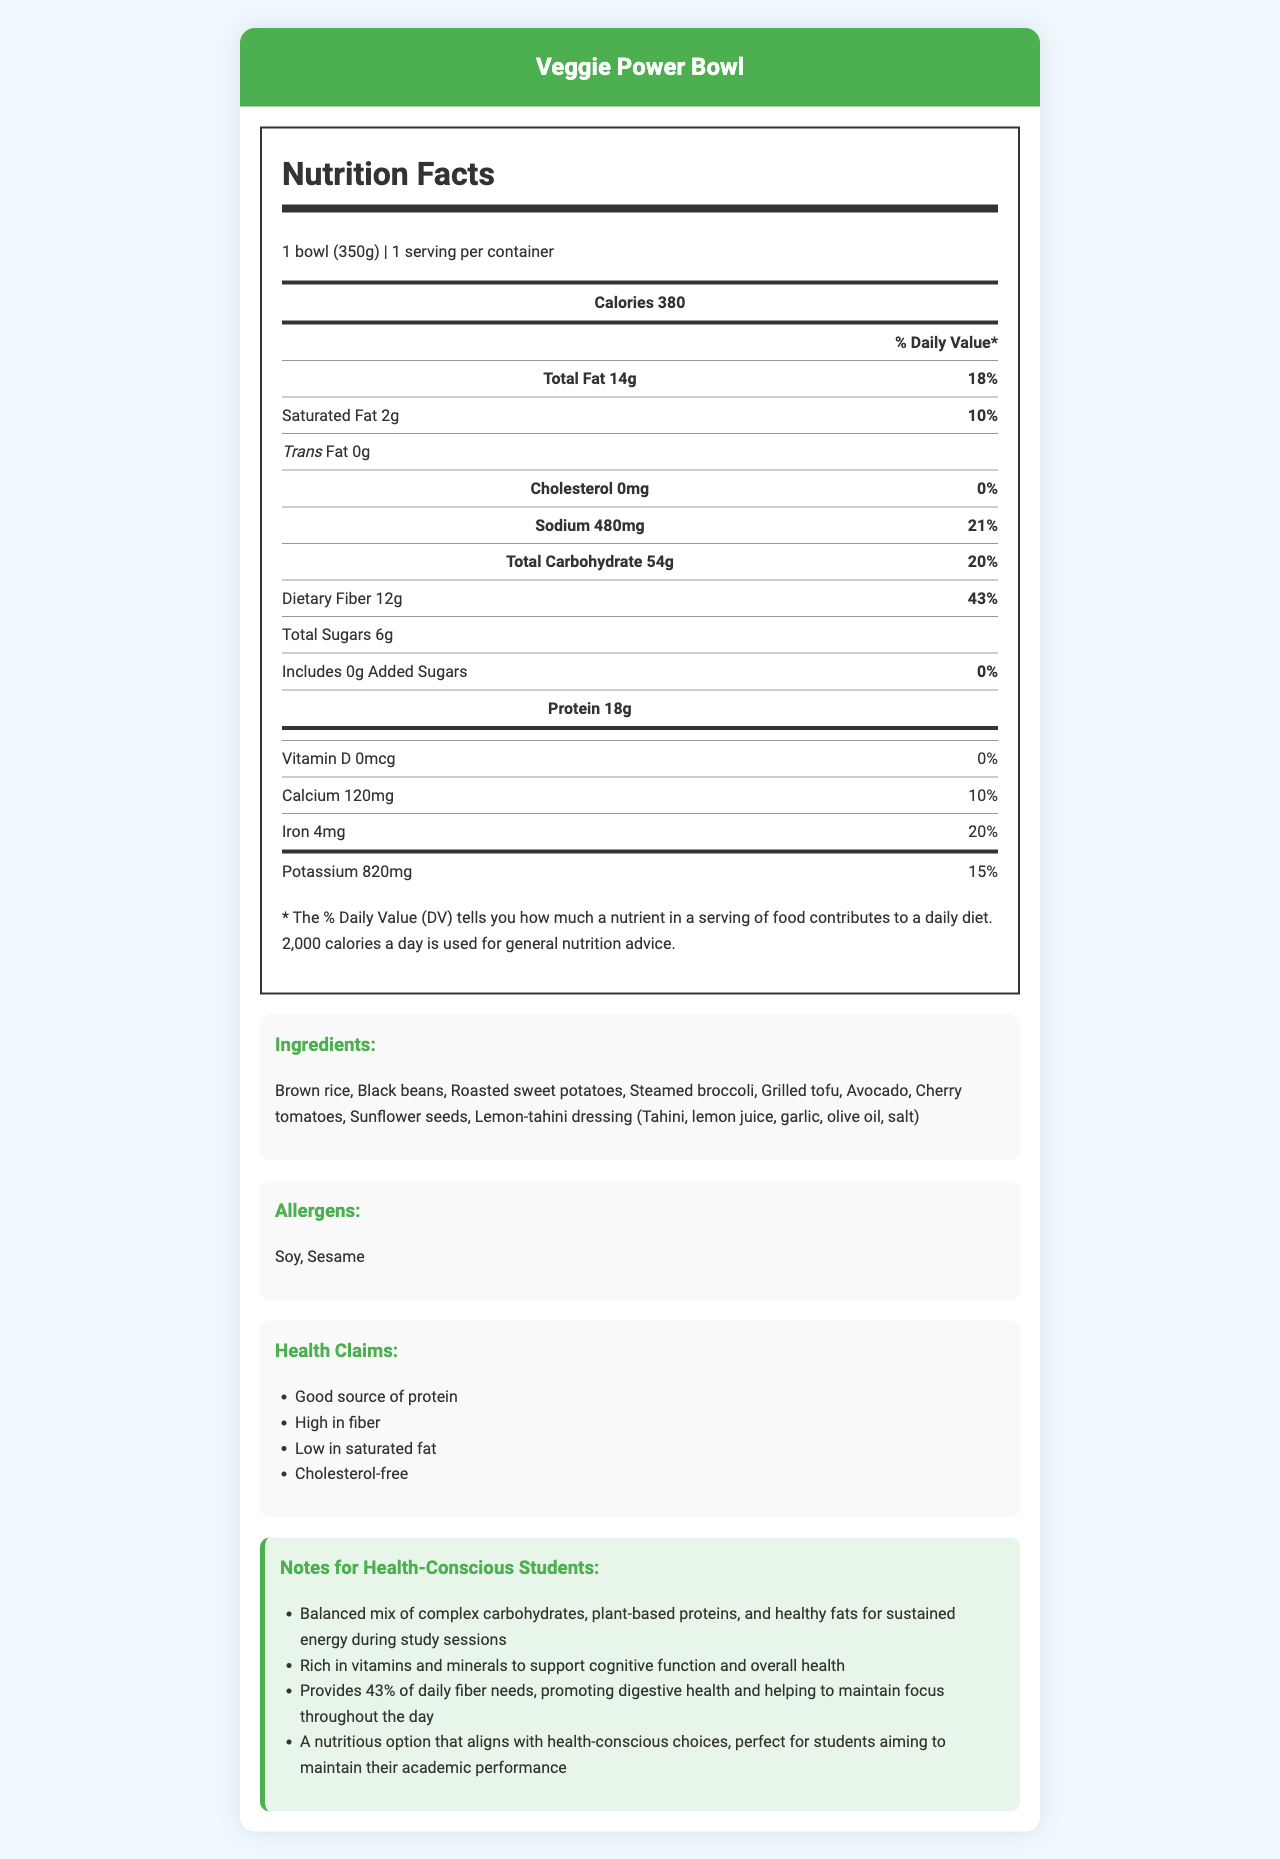what is the calorie count for one serving of the Veggie Power Bowl? The nutrition label states that one serving of the Veggie Power Bowl contains 380 calories.
Answer: 380 How much dietary fiber is in one Veggie Power Bowl? The nutrition label indicates that the Veggie Power Bowl contains 12g of dietary fiber per serving.
Answer: 12g What is the daily value percentage for sodium in the Veggie Power Bowl? The nutrition label shows that the Veggie Power Bowl provides 21% of the daily value for sodium.
Answer: 21% Which ingredient(s) in the Veggie Power Bowl might cause allergies? The allergens section lists soy and sesame as potential allergens.
Answer: Soy and Sesame How much protein is in the Veggie Power Bowl? The nutrition label specifies that the Veggie Power Bowl contains 18g of protein per serving.
Answer: 18g What percentage of the daily value of calcium does one serving provide? The nutrition label shows that one serving provides 10% of the daily value for calcium.
Answer: 10% Is the Veggie Power Bowl cholesterol-free? The nutrition label states that the Veggie Power Bowl contains 0mg of cholesterol, meaning it is cholesterol-free.
Answer: Yes How many grams of total fat are in one Veggie Power Bowl? According to the nutrition label, one serving of the Veggie Power Bowl contains 14g of total fat.
Answer: 14g Which of the following is a health claim made about the Veggie Power Bowl? (A) Low in sodium (B) Good source of protein (C) Contains added sugars The health claims section lists "Good source of protein" along with other benefits, but not "Low in sodium" or "Contains added sugars".
Answer: B How much iron does one serving of the Veggie Power Bowl contain? (A) 2mg (B) 4mg (C) 6mg The nutrition label specifies that one serving contains 4mg of iron.
Answer: B Is there any added sugar in the Veggie Power Bowl? The nutrition label indicates that the Veggie Power Bowl contains 0g of added sugars.
Answer: No Summarize the overall nutritional benefits of the Veggie Power Bowl. The document highlights that the Veggie Power Bowl is rich in protein and fiber, low in saturated fat, and free of cholesterol. It contains essential vitamins and minerals, supports digestive health, and is designed to help maintain academic performance through balanced nutrition.
Answer: The Veggie Power Bowl is a balanced vegetarian meal that provides a good source of protein, high fiber, low saturated fat, and cholesterol-free content. It includes a mix of complex carbohydrates, plant-based proteins, and healthy fats, making it suitable for sustained energy and cognitive function. What is the daily value percentage of potassium in one serving of the Veggie Power Bowl? According to the nutrition label, one serving provides 15% of the daily value for potassium.
Answer: 15% Is the Veggie Power Bowl a good option for students looking to maintain their academic performance? Why or why not? The notes section mentions that the Veggie Power Bowl provides balanced nutrients like complex carbohydrates, plant-based protein, and healthy fats, which help sustain energy, support cognitive function, and promote digestive health—key aspects for maintaining academic performance.
Answer: Yes, it is a good option. What is the daily value percentage of Vitamin D in one serving of the Veggie Power Bowl? The nutrition label indicates that one serving provides 0% of the daily value for Vitamin D.
Answer: 0% How many servings are in one container of the Veggie Power Bowl? The document states that there is one serving per container.
Answer: 1 